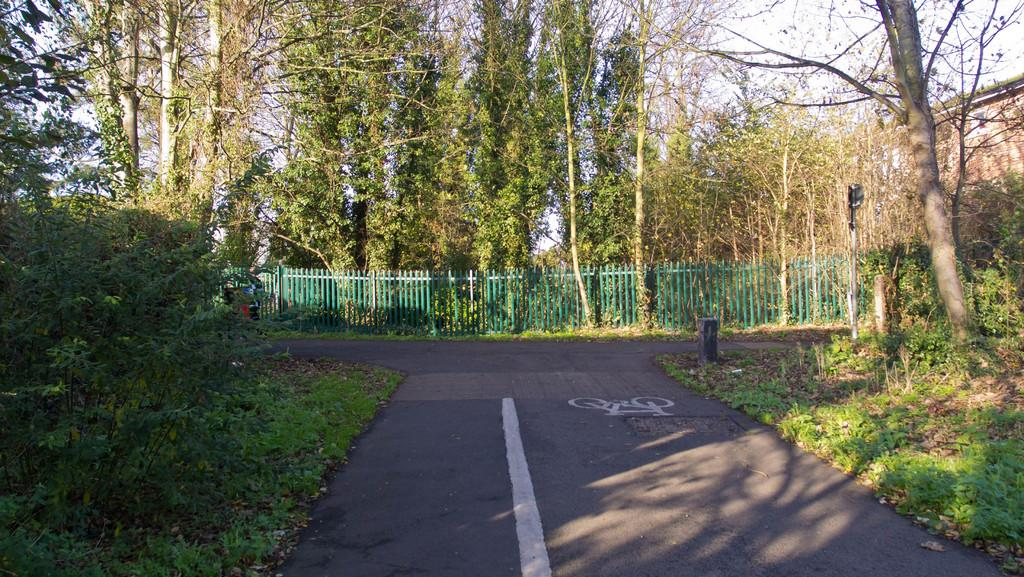What can be seen on the road in the image? There are painted lines on the road in the image. What is located near the grassland in the image? There is a fence on the grassland in the image. What type of vegetation is visible in the background of the image? There are plants and trees in the background of the image. Who is the owner of the salt in the image? There is no salt present in the image, so it is not possible to determine an owner. How does the death of the plants affect the image? There are no dead plants in the image, so their death does not affect the image. 